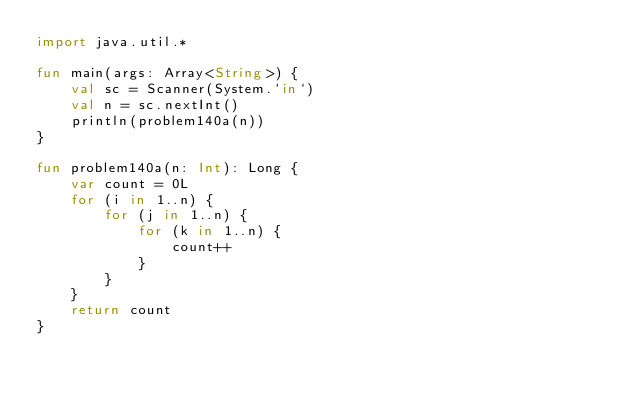<code> <loc_0><loc_0><loc_500><loc_500><_Kotlin_>import java.util.*

fun main(args: Array<String>) {
    val sc = Scanner(System.`in`)
    val n = sc.nextInt()
    println(problem140a(n))
}

fun problem140a(n: Int): Long {
    var count = 0L
    for (i in 1..n) {
        for (j in 1..n) {
            for (k in 1..n) {
                count++
            }
        }
    }
    return count
}</code> 